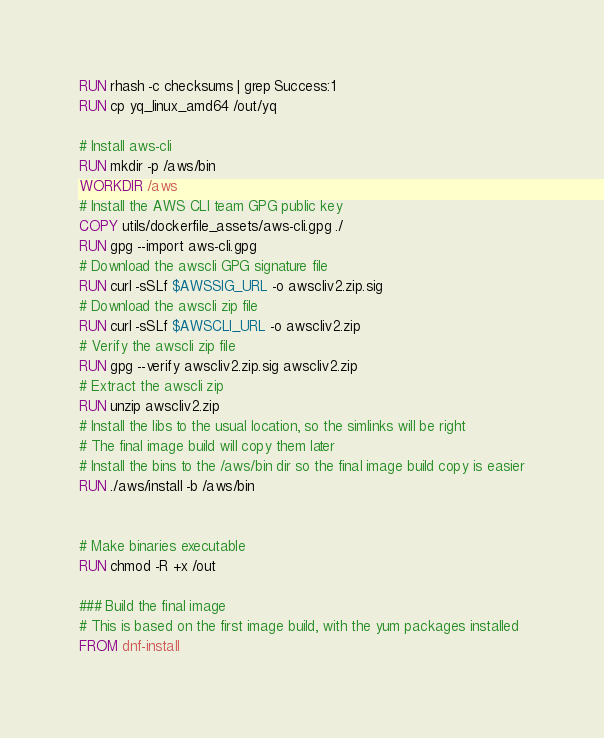Convert code to text. <code><loc_0><loc_0><loc_500><loc_500><_Dockerfile_>RUN rhash -c checksums | grep Success:1
RUN cp yq_linux_amd64 /out/yq

# Install aws-cli
RUN mkdir -p /aws/bin
WORKDIR /aws
# Install the AWS CLI team GPG public key
COPY utils/dockerfile_assets/aws-cli.gpg ./
RUN gpg --import aws-cli.gpg
# Download the awscli GPG signature file
RUN curl -sSLf $AWSSIG_URL -o awscliv2.zip.sig
# Download the awscli zip file
RUN curl -sSLf $AWSCLI_URL -o awscliv2.zip
# Verify the awscli zip file
RUN gpg --verify awscliv2.zip.sig awscliv2.zip
# Extract the awscli zip
RUN unzip awscliv2.zip
# Install the libs to the usual location, so the simlinks will be right
# The final image build will copy them later
# Install the bins to the /aws/bin dir so the final image build copy is easier
RUN ./aws/install -b /aws/bin


# Make binaries executable
RUN chmod -R +x /out

### Build the final image
# This is based on the first image build, with the yum packages installed
FROM dnf-install
</code> 